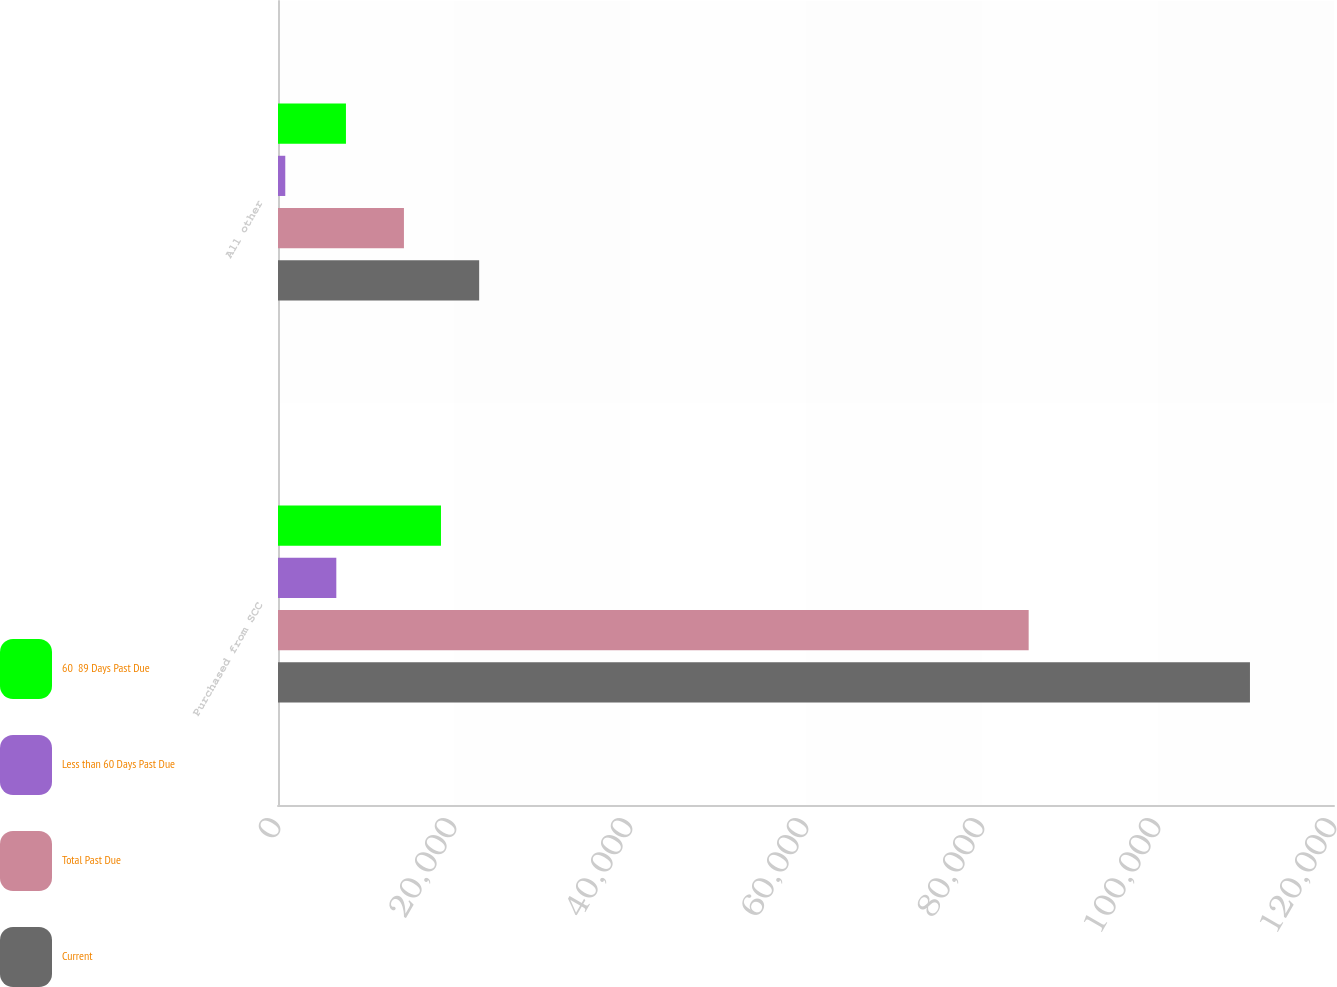Convert chart. <chart><loc_0><loc_0><loc_500><loc_500><stacked_bar_chart><ecel><fcel>Purchased from SCC<fcel>All other<nl><fcel>60  89 Days Past Due<fcel>18520<fcel>7722<nl><fcel>Less than 60 Days Past Due<fcel>6627<fcel>827<nl><fcel>Total Past Due<fcel>85303<fcel>14311<nl><fcel>Current<fcel>110450<fcel>22860<nl></chart> 